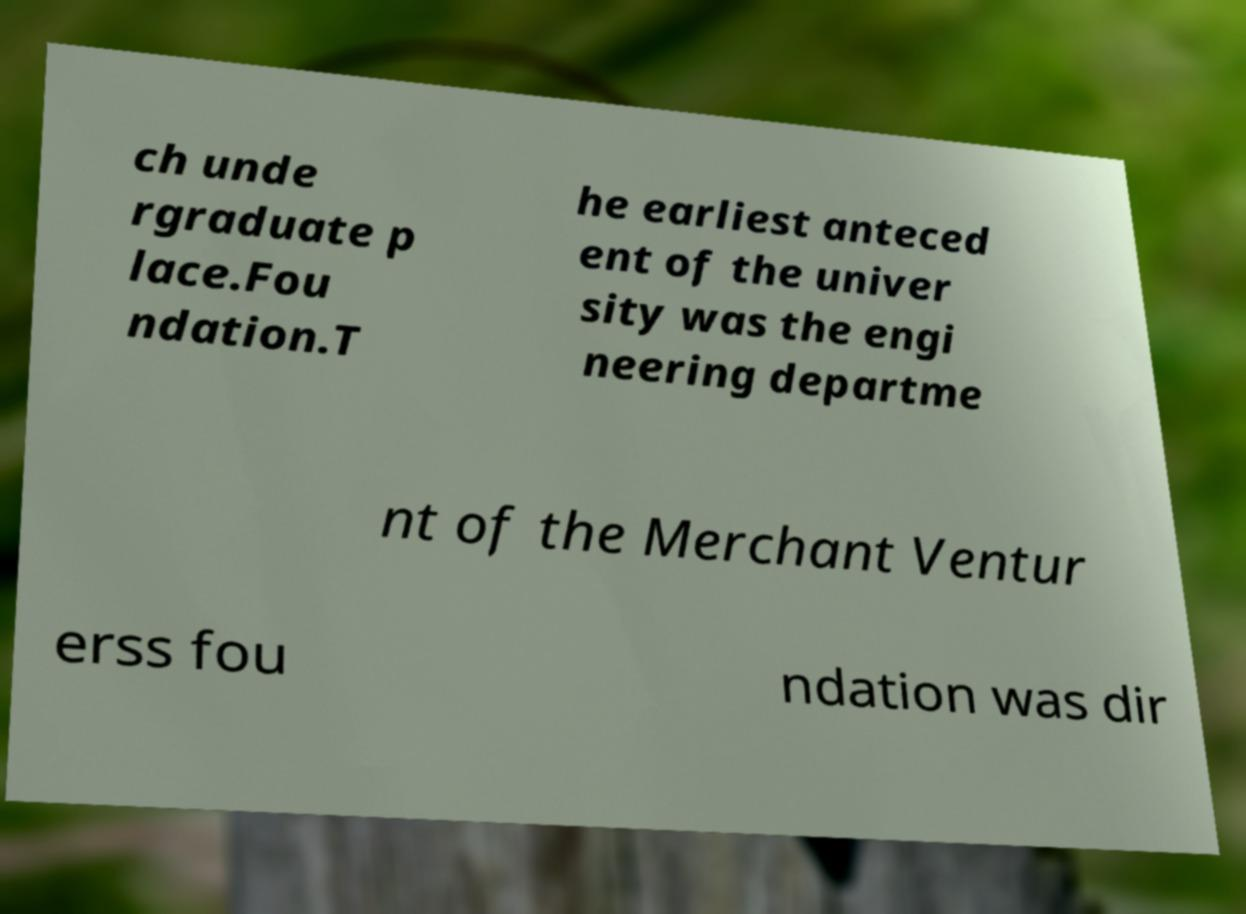There's text embedded in this image that I need extracted. Can you transcribe it verbatim? ch unde rgraduate p lace.Fou ndation.T he earliest anteced ent of the univer sity was the engi neering departme nt of the Merchant Ventur erss fou ndation was dir 